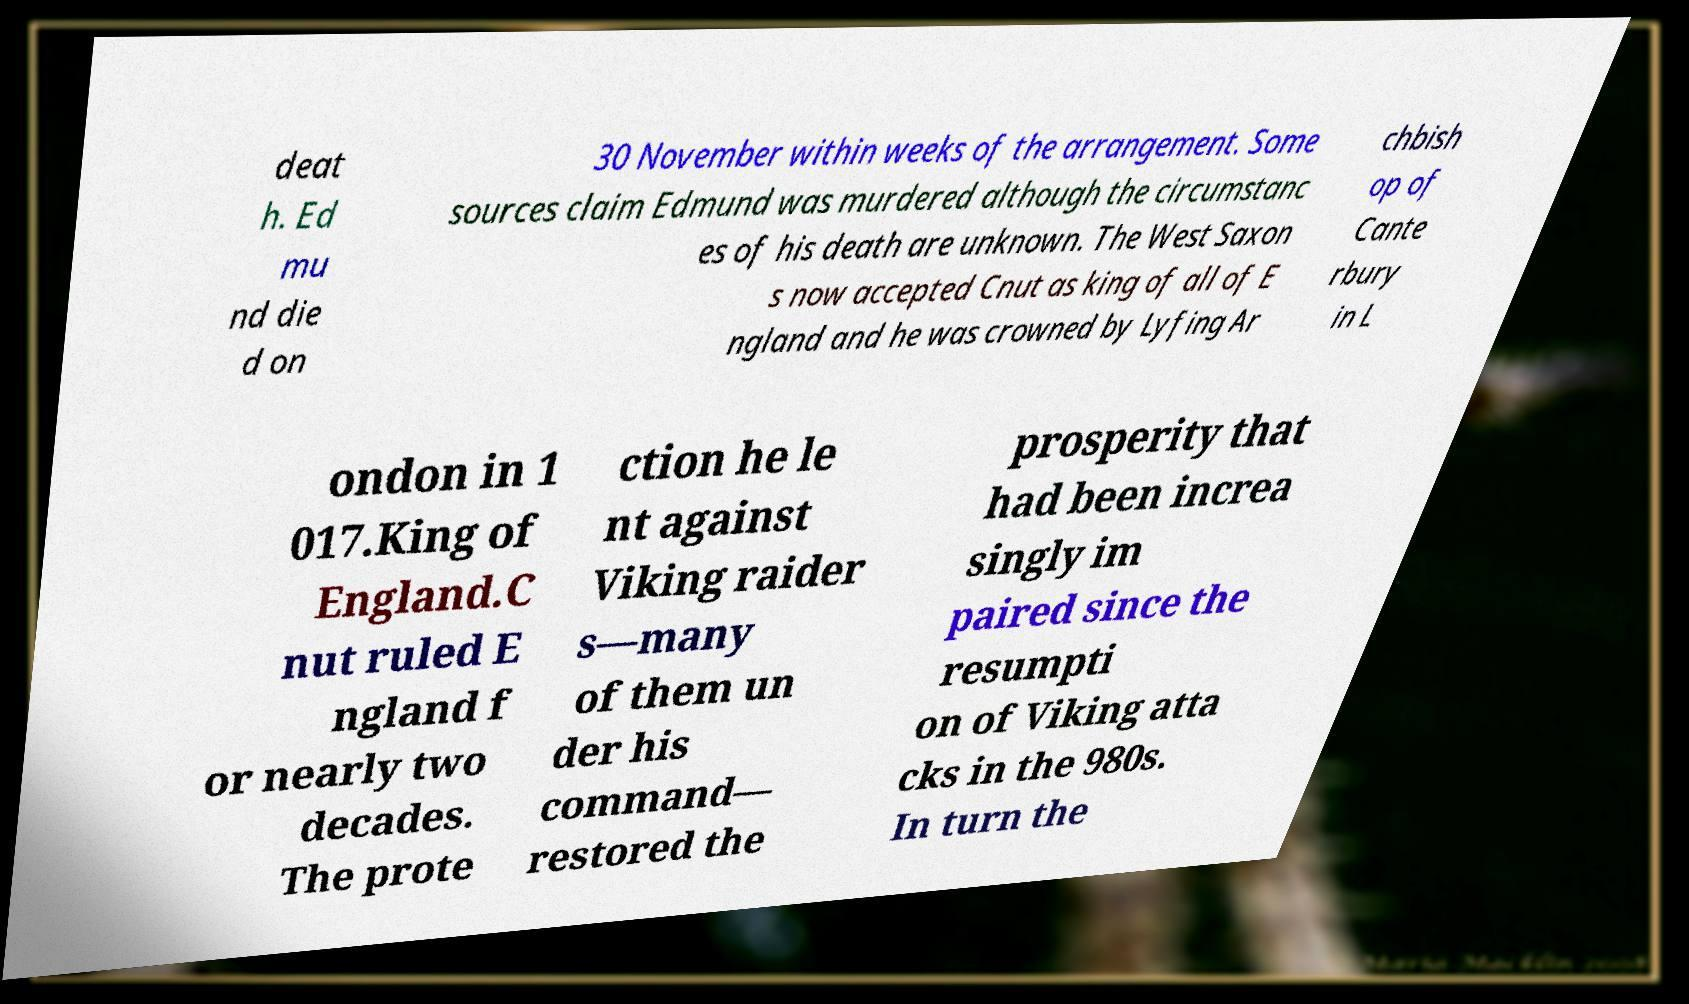Can you read and provide the text displayed in the image?This photo seems to have some interesting text. Can you extract and type it out for me? deat h. Ed mu nd die d on 30 November within weeks of the arrangement. Some sources claim Edmund was murdered although the circumstanc es of his death are unknown. The West Saxon s now accepted Cnut as king of all of E ngland and he was crowned by Lyfing Ar chbish op of Cante rbury in L ondon in 1 017.King of England.C nut ruled E ngland f or nearly two decades. The prote ction he le nt against Viking raider s—many of them un der his command— restored the prosperity that had been increa singly im paired since the resumpti on of Viking atta cks in the 980s. In turn the 